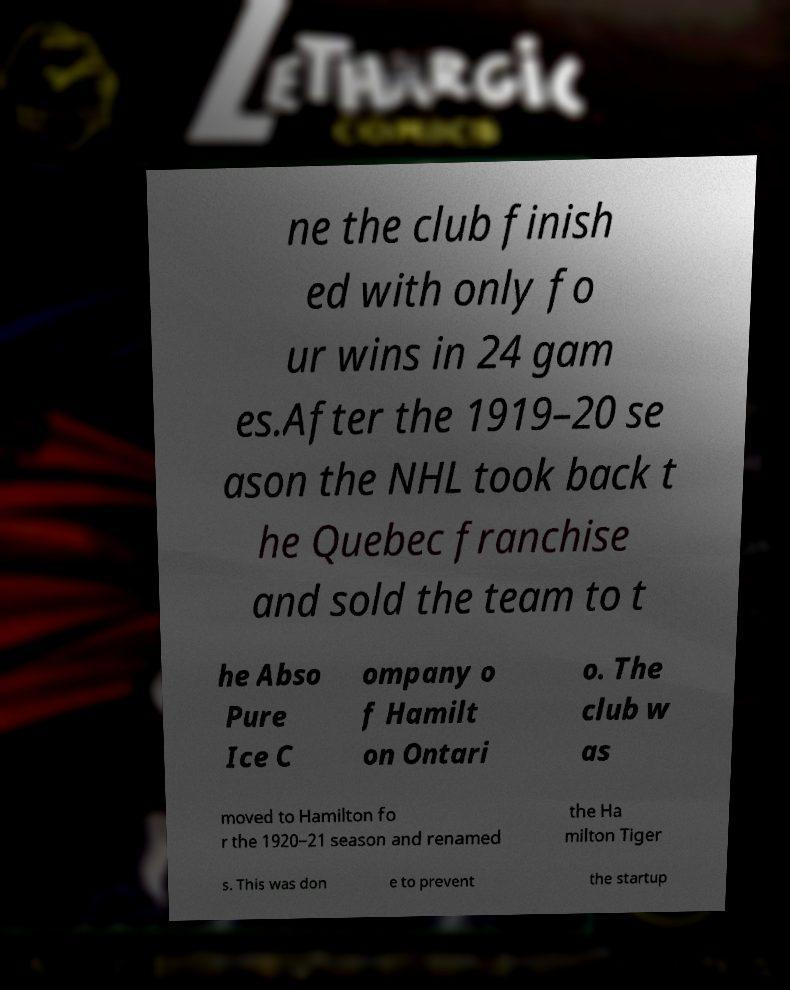I need the written content from this picture converted into text. Can you do that? ne the club finish ed with only fo ur wins in 24 gam es.After the 1919–20 se ason the NHL took back t he Quebec franchise and sold the team to t he Abso Pure Ice C ompany o f Hamilt on Ontari o. The club w as moved to Hamilton fo r the 1920–21 season and renamed the Ha milton Tiger s. This was don e to prevent the startup 